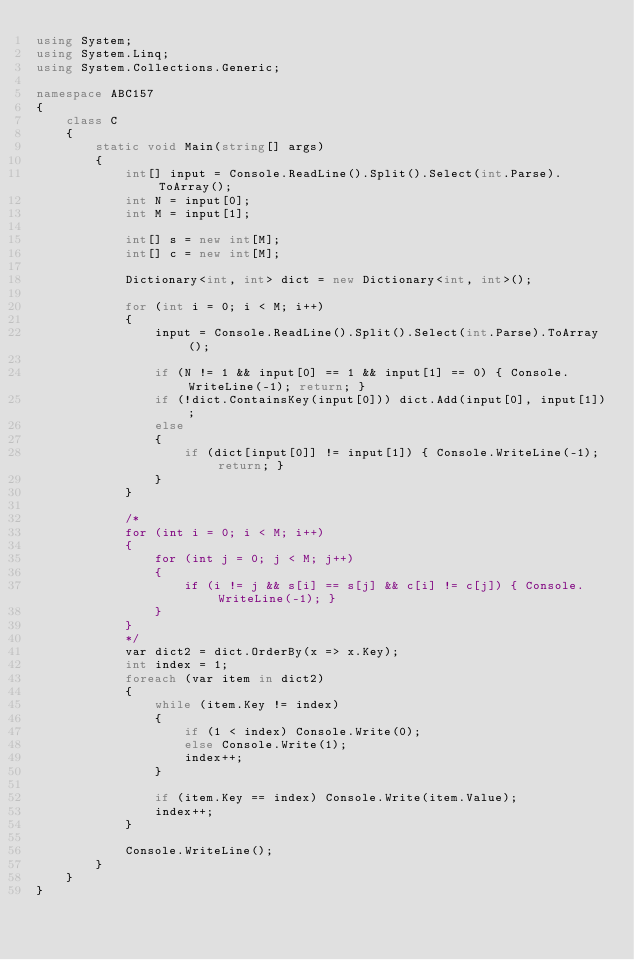<code> <loc_0><loc_0><loc_500><loc_500><_C#_>using System;
using System.Linq;
using System.Collections.Generic;

namespace ABC157
{
    class C
    {
        static void Main(string[] args)
        {
            int[] input = Console.ReadLine().Split().Select(int.Parse).ToArray();
            int N = input[0];
            int M = input[1];

            int[] s = new int[M];
            int[] c = new int[M];

            Dictionary<int, int> dict = new Dictionary<int, int>();

            for (int i = 0; i < M; i++)
            {
                input = Console.ReadLine().Split().Select(int.Parse).ToArray();

                if (N != 1 && input[0] == 1 && input[1] == 0) { Console.WriteLine(-1); return; }
                if (!dict.ContainsKey(input[0])) dict.Add(input[0], input[1]);
                else
                {
                    if (dict[input[0]] != input[1]) { Console.WriteLine(-1); return; }
                }
            }

            /*
            for (int i = 0; i < M; i++)
            {
                for (int j = 0; j < M; j++)
                {
                    if (i != j && s[i] == s[j] && c[i] != c[j]) { Console.WriteLine(-1); }
                }
            }
            */
            var dict2 = dict.OrderBy(x => x.Key);
            int index = 1;
            foreach (var item in dict2)
            {
                while (item.Key != index)
                {
                    if (1 < index) Console.Write(0);
                    else Console.Write(1);
                    index++;
                }

                if (item.Key == index) Console.Write(item.Value);
                index++;
            }

            Console.WriteLine();
        }
    }
}
</code> 